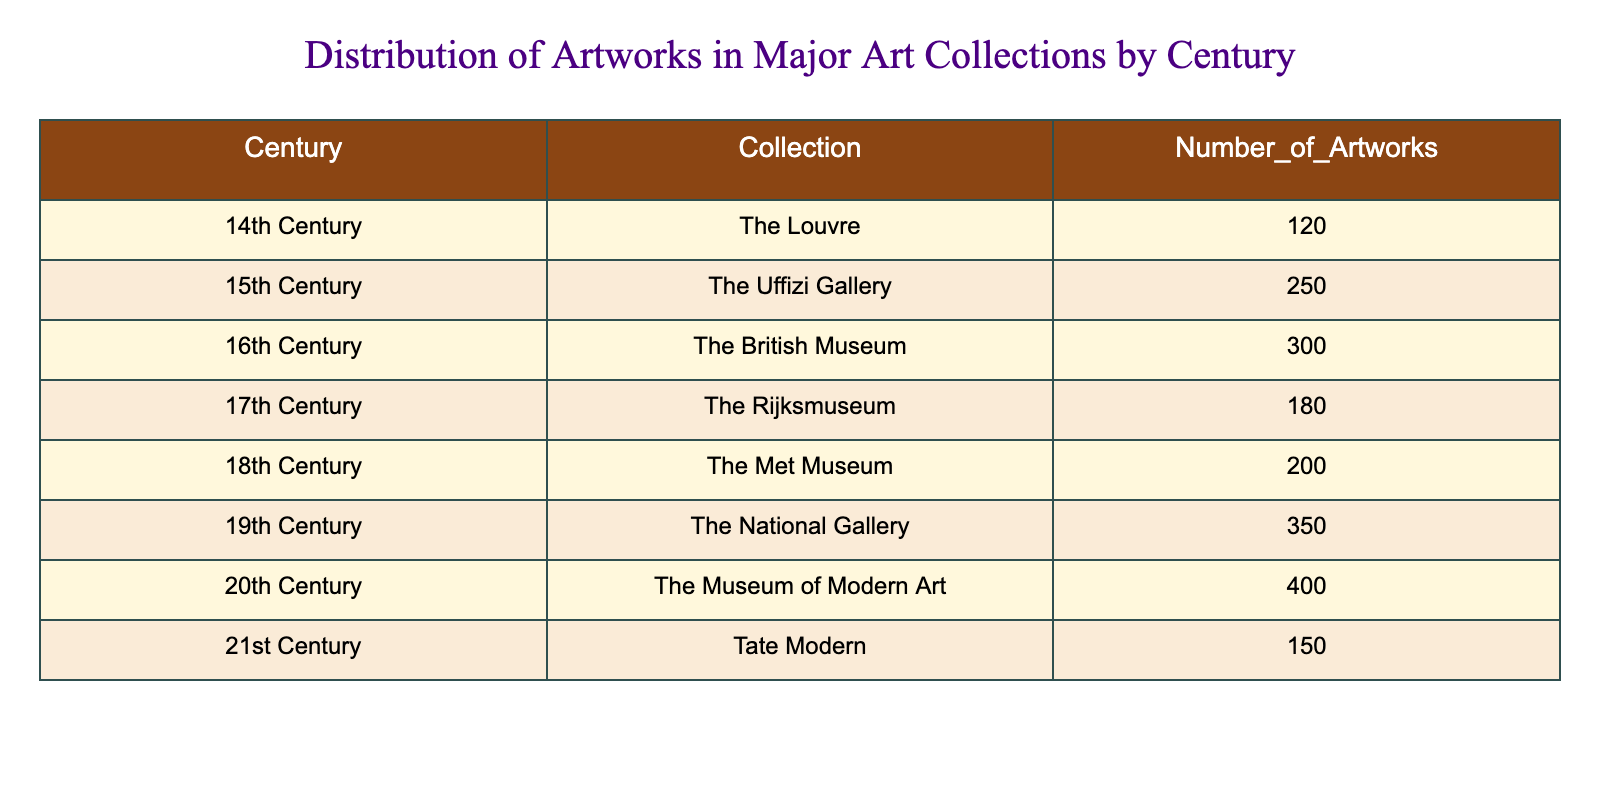What is the total number of artworks in the 19th Century? The number of artworks in the 19th Century is listed as 350 in the table.
Answer: 350 Which century has the highest number of artworks? According to the table, the 20th Century has the highest number of artworks at 400.
Answer: 20th Century What is the difference in the number of artworks between the 15th Century and the 17th Century? The 15th Century has 250 artworks and the 17th Century has 180 artworks. The difference is 250 - 180 = 70.
Answer: 70 Is it true that The Louvre has more artworks than The Met Museum? The Louvre has 120 artworks while The Met Museum has 200. Thus, it is false that The Louvre has more artworks.
Answer: No What is the average number of artworks across all centuries listed in the table? To find the average, sum the number of artworks across all centuries: 120 + 250 + 300 + 180 + 200 + 350 + 400 + 150 = 1950. Since there are 8 centuries, the average is 1950 / 8 = 243.75.
Answer: 243.75 Which century has the least number of artworks and what is that number? The 14th Century has the least number of artworks at 120, as seen in the table.
Answer: 14th Century, 120 How many more artworks are there in the 19th Century compared to the 18th Century? The 19th Century has 350 artworks, while the 18th Century has 200. Therefore, the difference is 350 - 200 = 150.
Answer: 150 Are there any collections with fewer than 200 artworks? The Louvre (120), The Rijksmuseum (180), and Tate Modern (150) all have fewer than 200 artworks. Thus, the answer is yes.
Answer: Yes 